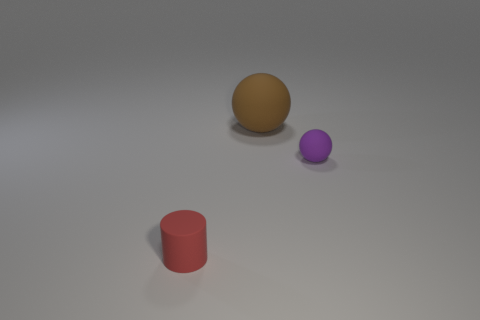Add 2 small red matte cylinders. How many objects exist? 5 Subtract all balls. How many objects are left? 1 Add 3 large brown objects. How many large brown objects are left? 4 Add 2 red things. How many red things exist? 3 Subtract 0 purple cubes. How many objects are left? 3 Subtract all purple objects. Subtract all big brown rubber balls. How many objects are left? 1 